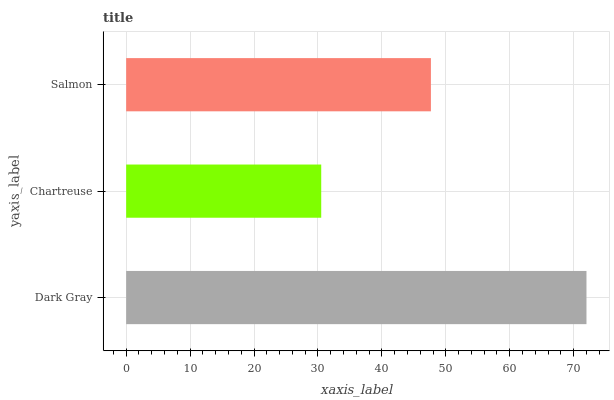Is Chartreuse the minimum?
Answer yes or no. Yes. Is Dark Gray the maximum?
Answer yes or no. Yes. Is Salmon the minimum?
Answer yes or no. No. Is Salmon the maximum?
Answer yes or no. No. Is Salmon greater than Chartreuse?
Answer yes or no. Yes. Is Chartreuse less than Salmon?
Answer yes or no. Yes. Is Chartreuse greater than Salmon?
Answer yes or no. No. Is Salmon less than Chartreuse?
Answer yes or no. No. Is Salmon the high median?
Answer yes or no. Yes. Is Salmon the low median?
Answer yes or no. Yes. Is Chartreuse the high median?
Answer yes or no. No. Is Chartreuse the low median?
Answer yes or no. No. 